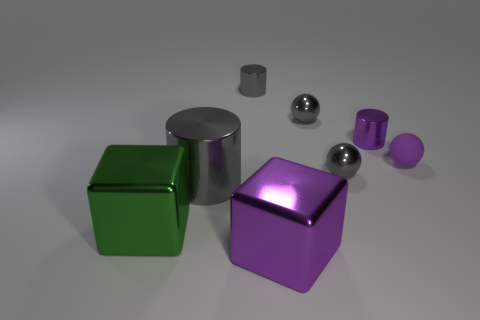Add 2 large green metal cubes. How many objects exist? 10 Subtract all cubes. How many objects are left? 6 Add 6 big cylinders. How many big cylinders exist? 7 Subtract 0 red balls. How many objects are left? 8 Subtract all small gray spheres. Subtract all gray shiny cylinders. How many objects are left? 4 Add 8 tiny gray metal cylinders. How many tiny gray metal cylinders are left? 9 